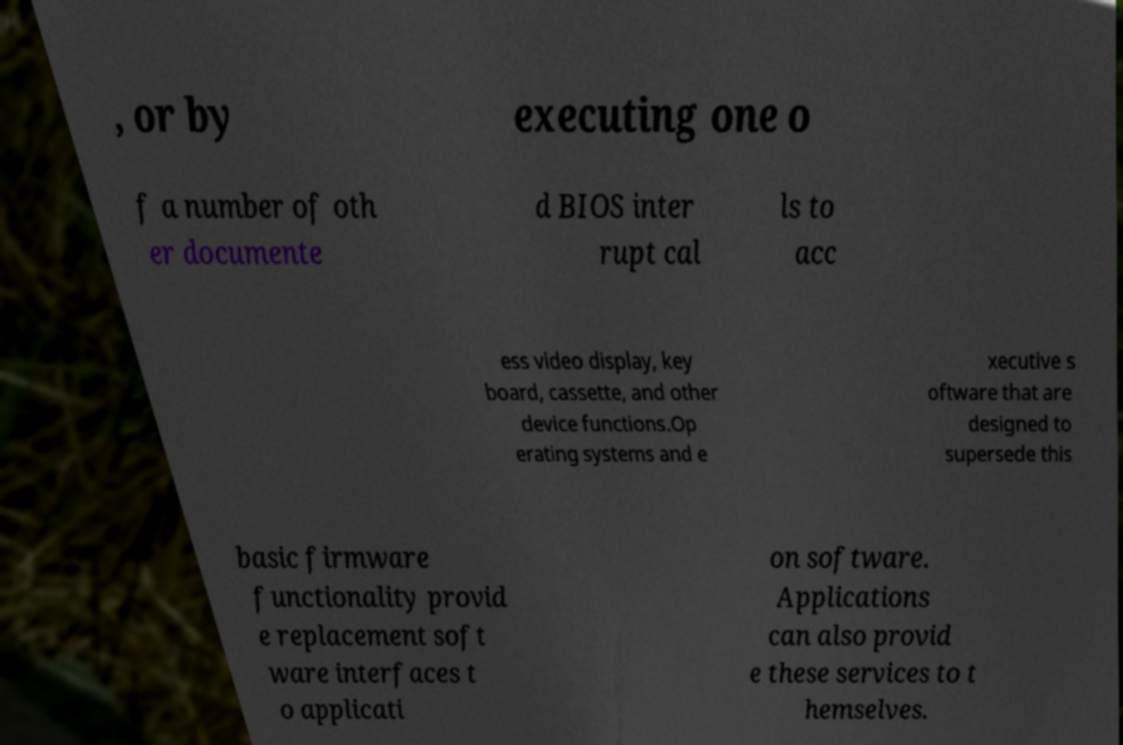Can you accurately transcribe the text from the provided image for me? , or by executing one o f a number of oth er documente d BIOS inter rupt cal ls to acc ess video display, key board, cassette, and other device functions.Op erating systems and e xecutive s oftware that are designed to supersede this basic firmware functionality provid e replacement soft ware interfaces t o applicati on software. Applications can also provid e these services to t hemselves. 